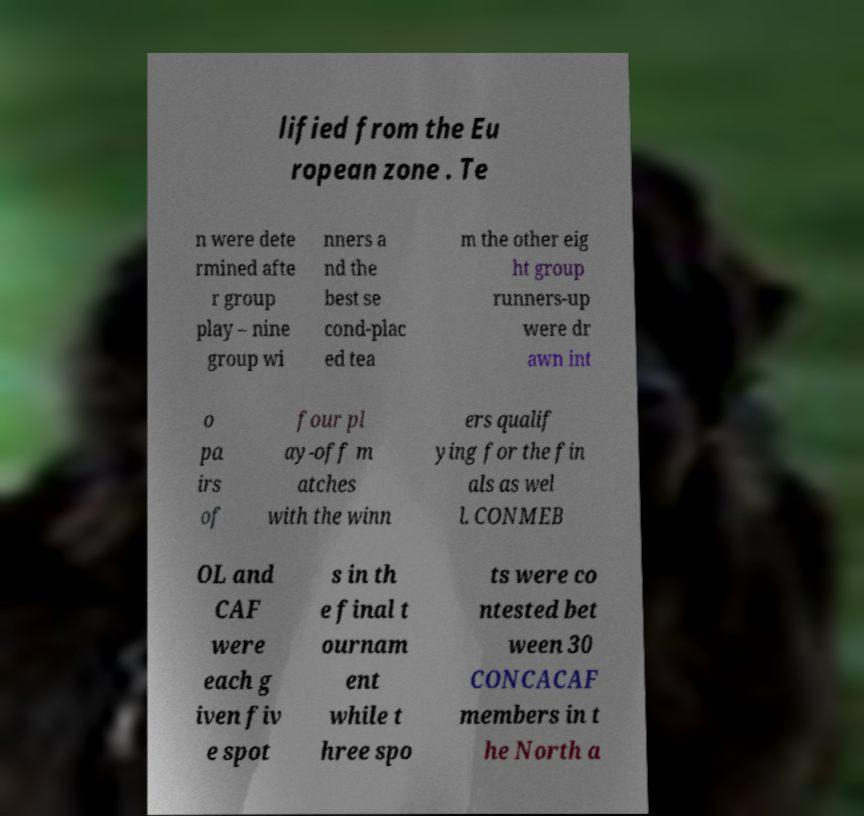For documentation purposes, I need the text within this image transcribed. Could you provide that? lified from the Eu ropean zone . Te n were dete rmined afte r group play – nine group wi nners a nd the best se cond-plac ed tea m the other eig ht group runners-up were dr awn int o pa irs of four pl ay-off m atches with the winn ers qualif ying for the fin als as wel l. CONMEB OL and CAF were each g iven fiv e spot s in th e final t ournam ent while t hree spo ts were co ntested bet ween 30 CONCACAF members in t he North a 